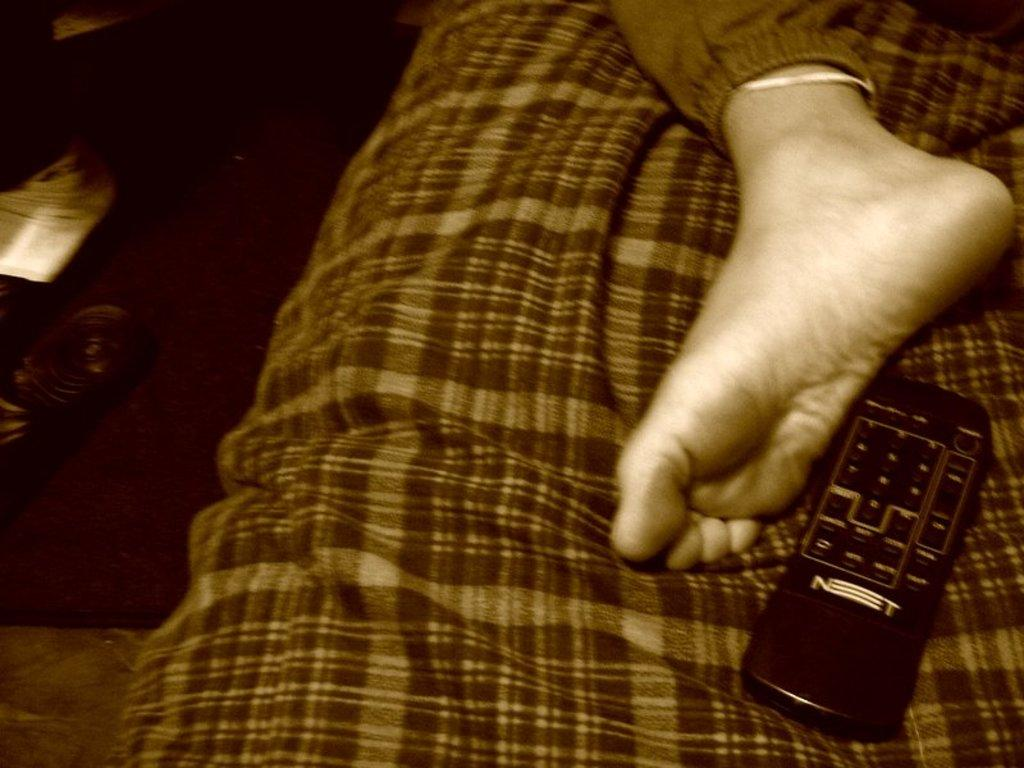<image>
Write a terse but informative summary of the picture. A foot is near a remote that has a word on it that starts with an N. 